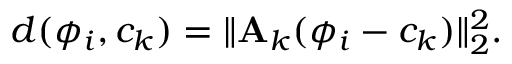<formula> <loc_0><loc_0><loc_500><loc_500>d ( \phi _ { i } , c _ { k } ) = \| { A } _ { k } ( \phi _ { i } - c _ { k } ) \| _ { 2 } ^ { 2 } .</formula> 